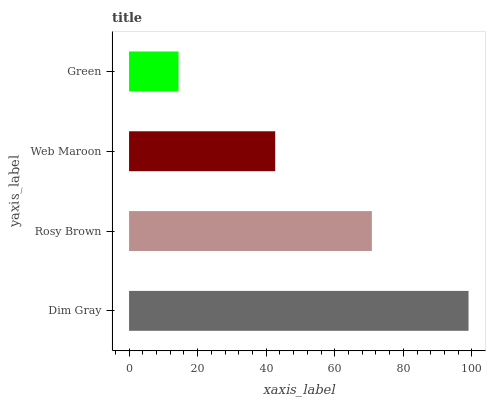Is Green the minimum?
Answer yes or no. Yes. Is Dim Gray the maximum?
Answer yes or no. Yes. Is Rosy Brown the minimum?
Answer yes or no. No. Is Rosy Brown the maximum?
Answer yes or no. No. Is Dim Gray greater than Rosy Brown?
Answer yes or no. Yes. Is Rosy Brown less than Dim Gray?
Answer yes or no. Yes. Is Rosy Brown greater than Dim Gray?
Answer yes or no. No. Is Dim Gray less than Rosy Brown?
Answer yes or no. No. Is Rosy Brown the high median?
Answer yes or no. Yes. Is Web Maroon the low median?
Answer yes or no. Yes. Is Web Maroon the high median?
Answer yes or no. No. Is Green the low median?
Answer yes or no. No. 